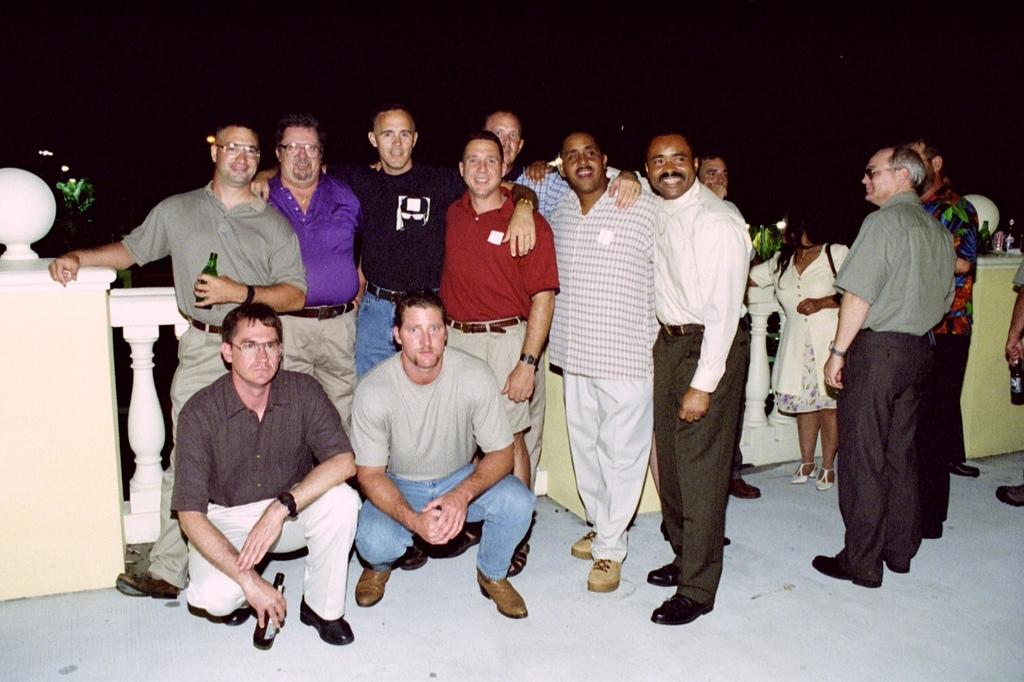What is the main subject of the image? The main subject of the image is men standing. Can you describe the background of the image? The background of the image is dark. What type of skate is being used by the men in the image? There is no skate present in the image; it only features men standing. How many hands are visible in the image? The provided facts do not mention hands, so it is not possible to determine the number of hands visible in the image. 